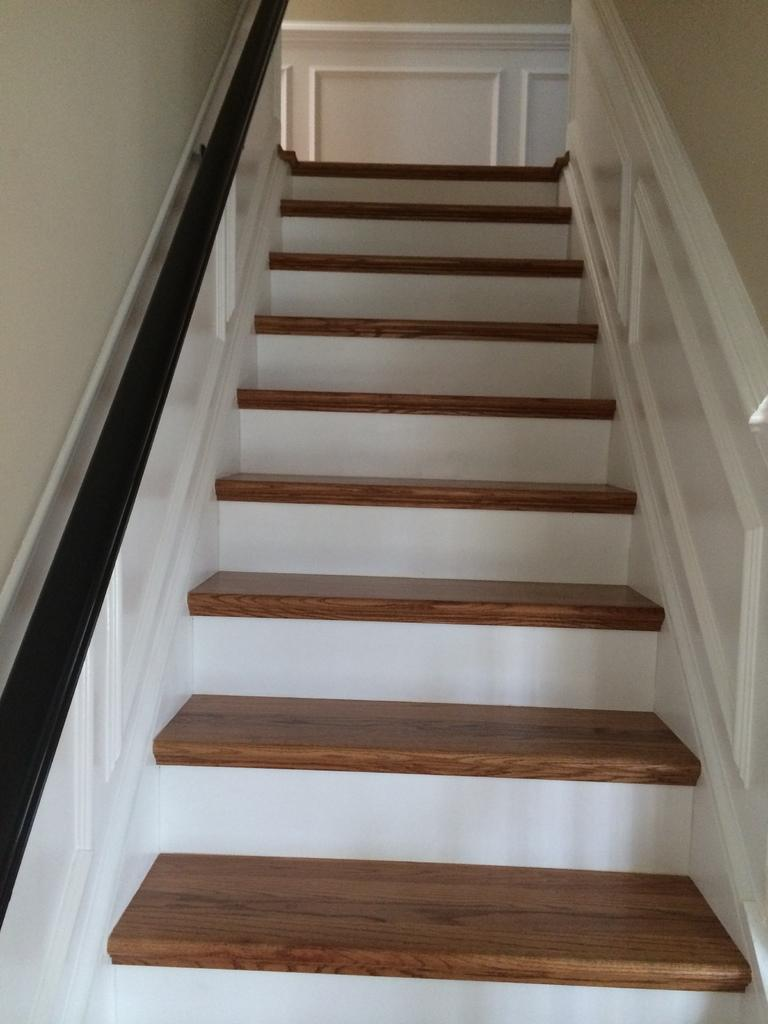What type of structure is present in the image? There is a staircase in the image. What can be seen in the background of the image? There is a wall in the background of the image. What type of organization is responsible for maintaining the staircase in the image? There is no information about an organization responsible for maintaining the staircase in the image. 